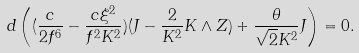Convert formula to latex. <formula><loc_0><loc_0><loc_500><loc_500>d \left ( ( \frac { c } { 2 f ^ { 6 } } - { \frac { c \xi ^ { 2 } } { f ^ { 2 } K ^ { 2 } } } ) ( J - { \frac { 2 } { K ^ { 2 } } } K \wedge Z ) + { \frac { \theta } { \sqrt { 2 } K ^ { 2 } } } J \right ) = 0 .</formula> 